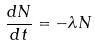<formula> <loc_0><loc_0><loc_500><loc_500>\frac { d N } { d t } = - \lambda N</formula> 